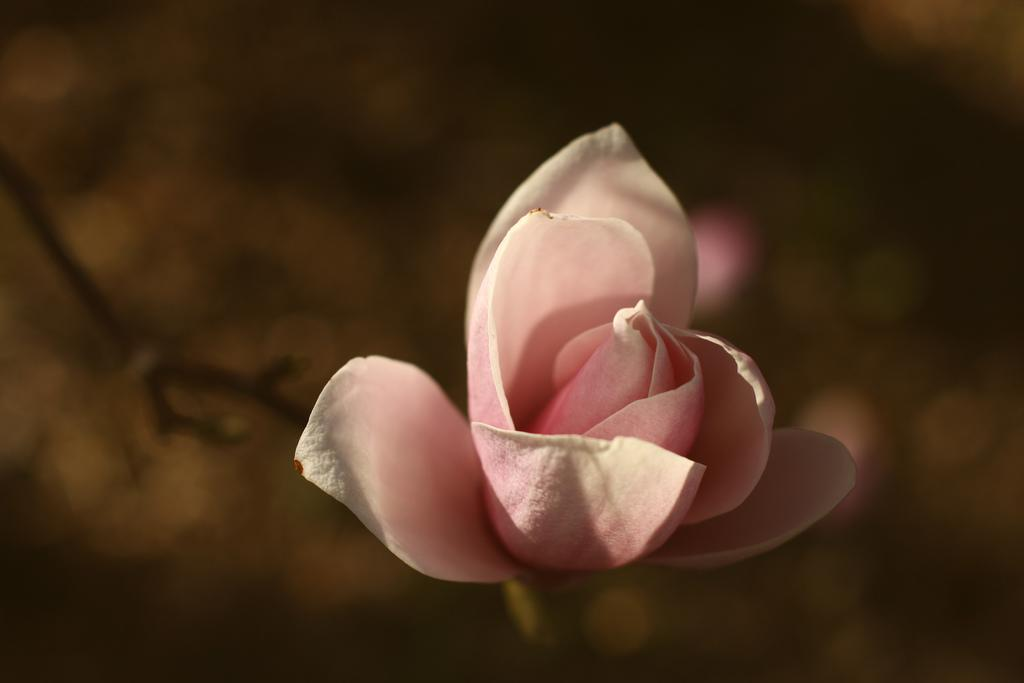What is the main subject of the image? There is a flower in the center of the image. Can you see a volcano erupting in the background of the image? There is no volcano present in the image; it only features a flower in the center. What type of quill is used to draw the flower in the image? There is no indication that the image was drawn with a quill, and the presence of a quill is not mentioned in the provided facts. 